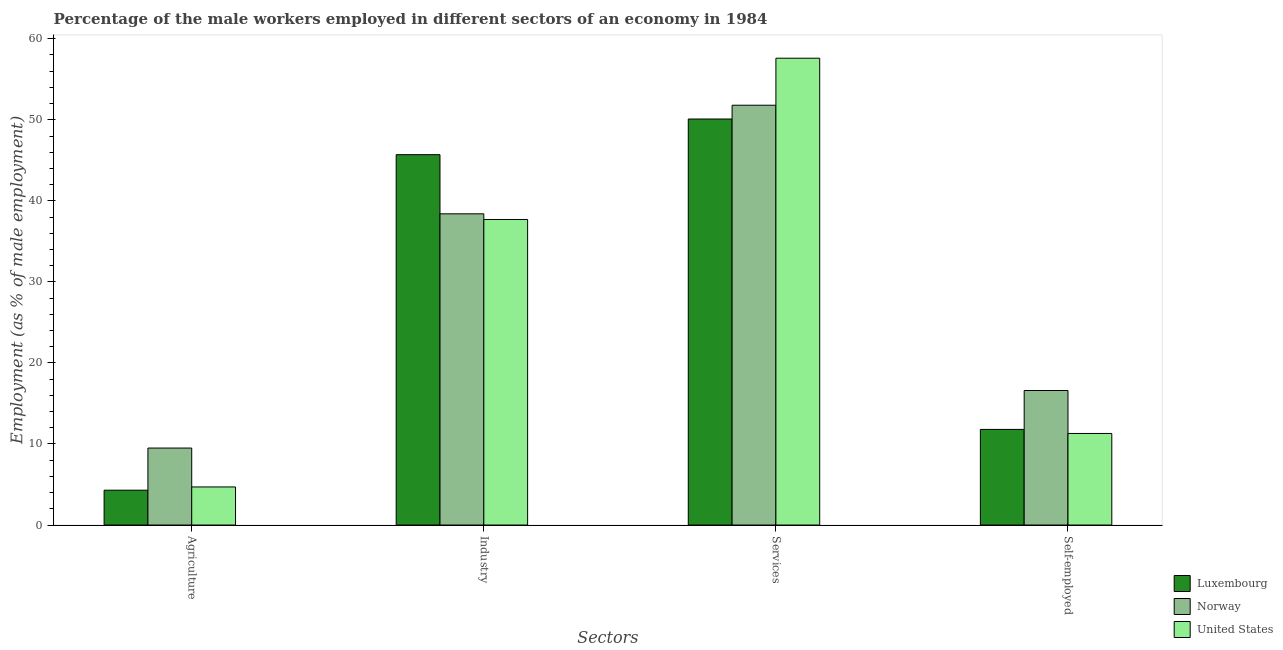How many different coloured bars are there?
Your response must be concise. 3. How many groups of bars are there?
Offer a terse response. 4. Are the number of bars per tick equal to the number of legend labels?
Your answer should be compact. Yes. Are the number of bars on each tick of the X-axis equal?
Ensure brevity in your answer.  Yes. How many bars are there on the 1st tick from the left?
Offer a very short reply. 3. What is the label of the 1st group of bars from the left?
Provide a short and direct response. Agriculture. What is the percentage of male workers in industry in Luxembourg?
Your answer should be compact. 45.7. Across all countries, what is the maximum percentage of male workers in services?
Your answer should be very brief. 57.6. Across all countries, what is the minimum percentage of male workers in agriculture?
Keep it short and to the point. 4.3. In which country was the percentage of male workers in industry maximum?
Give a very brief answer. Luxembourg. In which country was the percentage of male workers in industry minimum?
Ensure brevity in your answer.  United States. What is the total percentage of male workers in services in the graph?
Give a very brief answer. 159.5. What is the difference between the percentage of male workers in services in Norway and that in United States?
Make the answer very short. -5.8. What is the difference between the percentage of male workers in agriculture in United States and the percentage of male workers in industry in Luxembourg?
Provide a succinct answer. -41. What is the average percentage of male workers in agriculture per country?
Offer a terse response. 6.17. What is the difference between the percentage of self employed male workers and percentage of male workers in agriculture in Norway?
Your response must be concise. 7.1. In how many countries, is the percentage of male workers in services greater than 18 %?
Your response must be concise. 3. What is the ratio of the percentage of male workers in industry in United States to that in Norway?
Offer a very short reply. 0.98. Is the difference between the percentage of self employed male workers in Luxembourg and United States greater than the difference between the percentage of male workers in industry in Luxembourg and United States?
Your answer should be very brief. No. What is the difference between the highest and the second highest percentage of male workers in agriculture?
Make the answer very short. 4.8. What is the difference between the highest and the lowest percentage of male workers in agriculture?
Keep it short and to the point. 5.2. In how many countries, is the percentage of self employed male workers greater than the average percentage of self employed male workers taken over all countries?
Offer a very short reply. 1. What does the 1st bar from the left in Services represents?
Your response must be concise. Luxembourg. How many bars are there?
Your answer should be compact. 12. Are all the bars in the graph horizontal?
Your answer should be very brief. No. How many countries are there in the graph?
Offer a very short reply. 3. Does the graph contain any zero values?
Provide a short and direct response. No. Where does the legend appear in the graph?
Offer a very short reply. Bottom right. How are the legend labels stacked?
Provide a short and direct response. Vertical. What is the title of the graph?
Keep it short and to the point. Percentage of the male workers employed in different sectors of an economy in 1984. Does "Greece" appear as one of the legend labels in the graph?
Your response must be concise. No. What is the label or title of the X-axis?
Provide a short and direct response. Sectors. What is the label or title of the Y-axis?
Provide a succinct answer. Employment (as % of male employment). What is the Employment (as % of male employment) of Luxembourg in Agriculture?
Make the answer very short. 4.3. What is the Employment (as % of male employment) in Norway in Agriculture?
Your answer should be very brief. 9.5. What is the Employment (as % of male employment) of United States in Agriculture?
Make the answer very short. 4.7. What is the Employment (as % of male employment) in Luxembourg in Industry?
Your answer should be very brief. 45.7. What is the Employment (as % of male employment) in Norway in Industry?
Make the answer very short. 38.4. What is the Employment (as % of male employment) of United States in Industry?
Offer a terse response. 37.7. What is the Employment (as % of male employment) in Luxembourg in Services?
Give a very brief answer. 50.1. What is the Employment (as % of male employment) in Norway in Services?
Offer a very short reply. 51.8. What is the Employment (as % of male employment) in United States in Services?
Make the answer very short. 57.6. What is the Employment (as % of male employment) in Luxembourg in Self-employed?
Your answer should be very brief. 11.8. What is the Employment (as % of male employment) in Norway in Self-employed?
Ensure brevity in your answer.  16.6. What is the Employment (as % of male employment) of United States in Self-employed?
Give a very brief answer. 11.3. Across all Sectors, what is the maximum Employment (as % of male employment) of Luxembourg?
Give a very brief answer. 50.1. Across all Sectors, what is the maximum Employment (as % of male employment) of Norway?
Offer a terse response. 51.8. Across all Sectors, what is the maximum Employment (as % of male employment) of United States?
Your response must be concise. 57.6. Across all Sectors, what is the minimum Employment (as % of male employment) in Luxembourg?
Your answer should be compact. 4.3. Across all Sectors, what is the minimum Employment (as % of male employment) of Norway?
Provide a succinct answer. 9.5. Across all Sectors, what is the minimum Employment (as % of male employment) of United States?
Provide a short and direct response. 4.7. What is the total Employment (as % of male employment) of Luxembourg in the graph?
Offer a very short reply. 111.9. What is the total Employment (as % of male employment) in Norway in the graph?
Offer a terse response. 116.3. What is the total Employment (as % of male employment) of United States in the graph?
Provide a succinct answer. 111.3. What is the difference between the Employment (as % of male employment) of Luxembourg in Agriculture and that in Industry?
Offer a terse response. -41.4. What is the difference between the Employment (as % of male employment) in Norway in Agriculture and that in Industry?
Keep it short and to the point. -28.9. What is the difference between the Employment (as % of male employment) of United States in Agriculture and that in Industry?
Keep it short and to the point. -33. What is the difference between the Employment (as % of male employment) of Luxembourg in Agriculture and that in Services?
Keep it short and to the point. -45.8. What is the difference between the Employment (as % of male employment) of Norway in Agriculture and that in Services?
Ensure brevity in your answer.  -42.3. What is the difference between the Employment (as % of male employment) of United States in Agriculture and that in Services?
Make the answer very short. -52.9. What is the difference between the Employment (as % of male employment) in Luxembourg in Agriculture and that in Self-employed?
Keep it short and to the point. -7.5. What is the difference between the Employment (as % of male employment) in Luxembourg in Industry and that in Services?
Your answer should be compact. -4.4. What is the difference between the Employment (as % of male employment) of Norway in Industry and that in Services?
Offer a very short reply. -13.4. What is the difference between the Employment (as % of male employment) of United States in Industry and that in Services?
Your response must be concise. -19.9. What is the difference between the Employment (as % of male employment) of Luxembourg in Industry and that in Self-employed?
Give a very brief answer. 33.9. What is the difference between the Employment (as % of male employment) in Norway in Industry and that in Self-employed?
Ensure brevity in your answer.  21.8. What is the difference between the Employment (as % of male employment) in United States in Industry and that in Self-employed?
Offer a terse response. 26.4. What is the difference between the Employment (as % of male employment) in Luxembourg in Services and that in Self-employed?
Your answer should be very brief. 38.3. What is the difference between the Employment (as % of male employment) of Norway in Services and that in Self-employed?
Ensure brevity in your answer.  35.2. What is the difference between the Employment (as % of male employment) of United States in Services and that in Self-employed?
Make the answer very short. 46.3. What is the difference between the Employment (as % of male employment) in Luxembourg in Agriculture and the Employment (as % of male employment) in Norway in Industry?
Provide a succinct answer. -34.1. What is the difference between the Employment (as % of male employment) in Luxembourg in Agriculture and the Employment (as % of male employment) in United States in Industry?
Ensure brevity in your answer.  -33.4. What is the difference between the Employment (as % of male employment) of Norway in Agriculture and the Employment (as % of male employment) of United States in Industry?
Keep it short and to the point. -28.2. What is the difference between the Employment (as % of male employment) of Luxembourg in Agriculture and the Employment (as % of male employment) of Norway in Services?
Your answer should be compact. -47.5. What is the difference between the Employment (as % of male employment) in Luxembourg in Agriculture and the Employment (as % of male employment) in United States in Services?
Ensure brevity in your answer.  -53.3. What is the difference between the Employment (as % of male employment) in Norway in Agriculture and the Employment (as % of male employment) in United States in Services?
Offer a very short reply. -48.1. What is the difference between the Employment (as % of male employment) of Luxembourg in Agriculture and the Employment (as % of male employment) of Norway in Self-employed?
Provide a succinct answer. -12.3. What is the difference between the Employment (as % of male employment) in Norway in Agriculture and the Employment (as % of male employment) in United States in Self-employed?
Your answer should be compact. -1.8. What is the difference between the Employment (as % of male employment) in Luxembourg in Industry and the Employment (as % of male employment) in Norway in Services?
Provide a short and direct response. -6.1. What is the difference between the Employment (as % of male employment) of Norway in Industry and the Employment (as % of male employment) of United States in Services?
Give a very brief answer. -19.2. What is the difference between the Employment (as % of male employment) of Luxembourg in Industry and the Employment (as % of male employment) of Norway in Self-employed?
Provide a short and direct response. 29.1. What is the difference between the Employment (as % of male employment) in Luxembourg in Industry and the Employment (as % of male employment) in United States in Self-employed?
Provide a short and direct response. 34.4. What is the difference between the Employment (as % of male employment) of Norway in Industry and the Employment (as % of male employment) of United States in Self-employed?
Your response must be concise. 27.1. What is the difference between the Employment (as % of male employment) in Luxembourg in Services and the Employment (as % of male employment) in Norway in Self-employed?
Offer a terse response. 33.5. What is the difference between the Employment (as % of male employment) of Luxembourg in Services and the Employment (as % of male employment) of United States in Self-employed?
Your response must be concise. 38.8. What is the difference between the Employment (as % of male employment) of Norway in Services and the Employment (as % of male employment) of United States in Self-employed?
Provide a succinct answer. 40.5. What is the average Employment (as % of male employment) in Luxembourg per Sectors?
Provide a succinct answer. 27.98. What is the average Employment (as % of male employment) in Norway per Sectors?
Keep it short and to the point. 29.07. What is the average Employment (as % of male employment) in United States per Sectors?
Your answer should be compact. 27.82. What is the difference between the Employment (as % of male employment) of Luxembourg and Employment (as % of male employment) of Norway in Agriculture?
Your response must be concise. -5.2. What is the difference between the Employment (as % of male employment) in Luxembourg and Employment (as % of male employment) in United States in Agriculture?
Provide a succinct answer. -0.4. What is the difference between the Employment (as % of male employment) in Luxembourg and Employment (as % of male employment) in Norway in Industry?
Your answer should be compact. 7.3. What is the difference between the Employment (as % of male employment) in Luxembourg and Employment (as % of male employment) in Norway in Services?
Offer a terse response. -1.7. What is the difference between the Employment (as % of male employment) in Luxembourg and Employment (as % of male employment) in Norway in Self-employed?
Provide a succinct answer. -4.8. What is the difference between the Employment (as % of male employment) in Norway and Employment (as % of male employment) in United States in Self-employed?
Make the answer very short. 5.3. What is the ratio of the Employment (as % of male employment) in Luxembourg in Agriculture to that in Industry?
Your response must be concise. 0.09. What is the ratio of the Employment (as % of male employment) in Norway in Agriculture to that in Industry?
Your answer should be compact. 0.25. What is the ratio of the Employment (as % of male employment) of United States in Agriculture to that in Industry?
Offer a terse response. 0.12. What is the ratio of the Employment (as % of male employment) in Luxembourg in Agriculture to that in Services?
Make the answer very short. 0.09. What is the ratio of the Employment (as % of male employment) of Norway in Agriculture to that in Services?
Ensure brevity in your answer.  0.18. What is the ratio of the Employment (as % of male employment) in United States in Agriculture to that in Services?
Provide a succinct answer. 0.08. What is the ratio of the Employment (as % of male employment) of Luxembourg in Agriculture to that in Self-employed?
Your answer should be very brief. 0.36. What is the ratio of the Employment (as % of male employment) in Norway in Agriculture to that in Self-employed?
Provide a succinct answer. 0.57. What is the ratio of the Employment (as % of male employment) of United States in Agriculture to that in Self-employed?
Offer a terse response. 0.42. What is the ratio of the Employment (as % of male employment) in Luxembourg in Industry to that in Services?
Give a very brief answer. 0.91. What is the ratio of the Employment (as % of male employment) of Norway in Industry to that in Services?
Give a very brief answer. 0.74. What is the ratio of the Employment (as % of male employment) in United States in Industry to that in Services?
Give a very brief answer. 0.65. What is the ratio of the Employment (as % of male employment) in Luxembourg in Industry to that in Self-employed?
Make the answer very short. 3.87. What is the ratio of the Employment (as % of male employment) in Norway in Industry to that in Self-employed?
Offer a terse response. 2.31. What is the ratio of the Employment (as % of male employment) of United States in Industry to that in Self-employed?
Give a very brief answer. 3.34. What is the ratio of the Employment (as % of male employment) in Luxembourg in Services to that in Self-employed?
Provide a succinct answer. 4.25. What is the ratio of the Employment (as % of male employment) of Norway in Services to that in Self-employed?
Provide a short and direct response. 3.12. What is the ratio of the Employment (as % of male employment) in United States in Services to that in Self-employed?
Ensure brevity in your answer.  5.1. What is the difference between the highest and the second highest Employment (as % of male employment) of United States?
Give a very brief answer. 19.9. What is the difference between the highest and the lowest Employment (as % of male employment) in Luxembourg?
Your answer should be very brief. 45.8. What is the difference between the highest and the lowest Employment (as % of male employment) of Norway?
Ensure brevity in your answer.  42.3. What is the difference between the highest and the lowest Employment (as % of male employment) of United States?
Give a very brief answer. 52.9. 